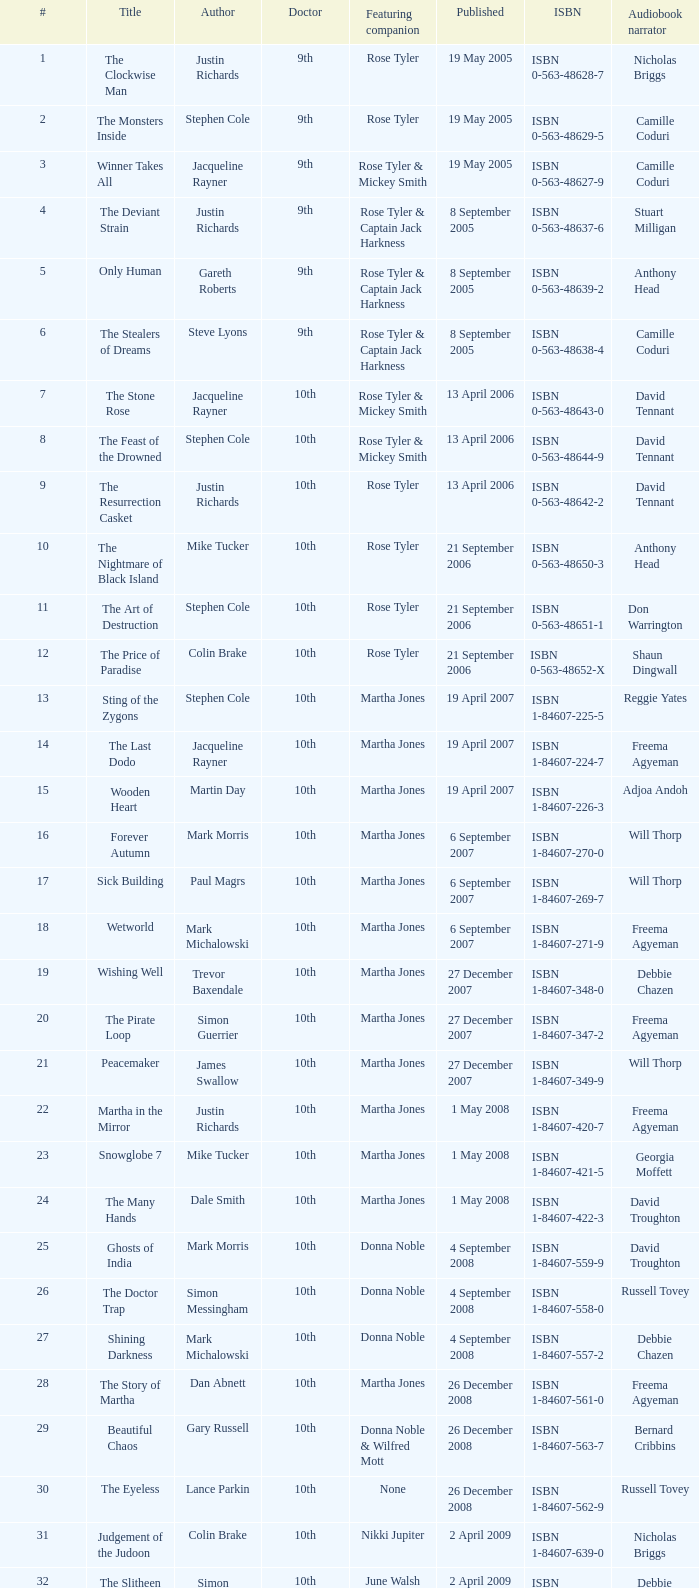What is the release date of the book narrated by michael maloney? 29 September 2011. 